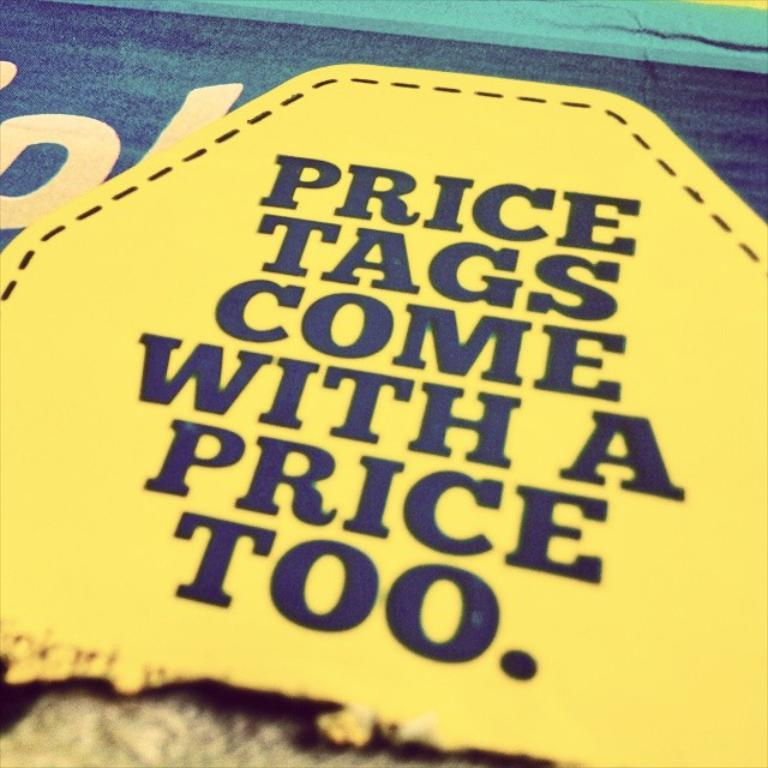Provide a one-sentence caption for the provided image. A patch that reads, Price tags come with a price too. 